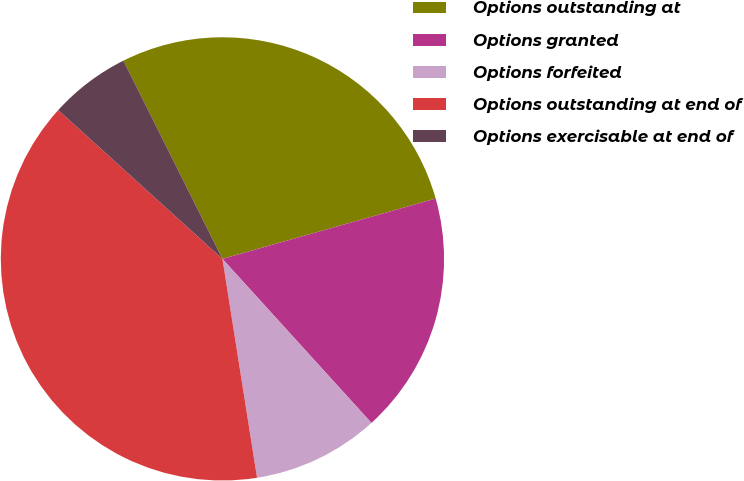Convert chart to OTSL. <chart><loc_0><loc_0><loc_500><loc_500><pie_chart><fcel>Options outstanding at<fcel>Options granted<fcel>Options forfeited<fcel>Options outstanding at end of<fcel>Options exercisable at end of<nl><fcel>27.98%<fcel>17.65%<fcel>9.24%<fcel>39.21%<fcel>5.91%<nl></chart> 